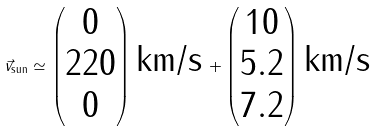Convert formula to latex. <formula><loc_0><loc_0><loc_500><loc_500>\vec { v } _ { \text {sun} } \simeq \begin{pmatrix} 0 \\ 2 2 0 \\ 0 \end{pmatrix} \, \text {km/s} \, + \begin{pmatrix} 1 0 \\ 5 . 2 \\ 7 . 2 \end{pmatrix} \, \text {km/s}</formula> 